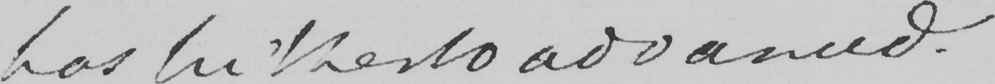What does this handwritten line say? has hitherto advanced. 